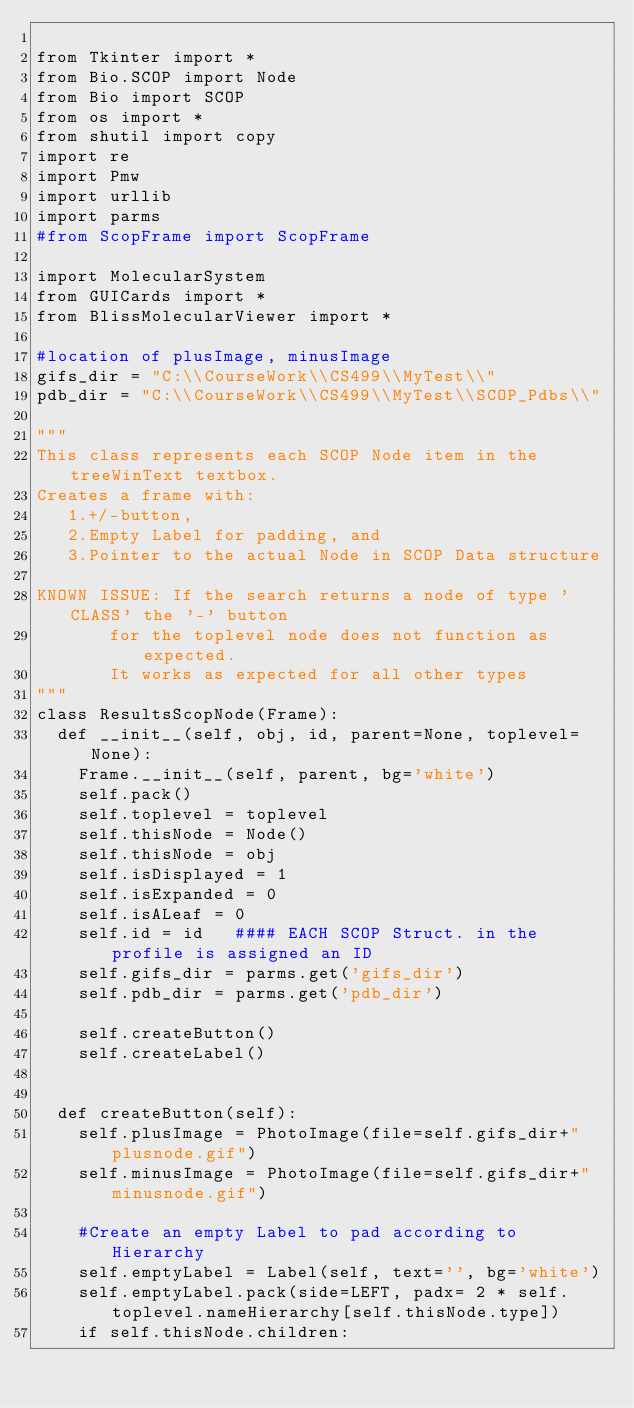<code> <loc_0><loc_0><loc_500><loc_500><_Python_>
from Tkinter import *
from Bio.SCOP import Node
from Bio import SCOP
from os import *
from shutil import copy
import re
import Pmw
import urllib
import parms
#from ScopFrame import ScopFrame

import MolecularSystem
from GUICards import *
from BlissMolecularViewer import *

#location of plusImage, minusImage
gifs_dir = "C:\\CourseWork\\CS499\\MyTest\\"
pdb_dir = "C:\\CourseWork\\CS499\\MyTest\\SCOP_Pdbs\\"

"""
This class represents each SCOP Node item in the treeWinText textbox.
Creates a frame with:
	 1.+/-button, 
	 2.Empty Label for padding, and  
	 3.Pointer to the actual Node in SCOP Data structure

KNOWN ISSUE: If the search returns a node of type 'CLASS' the '-' button 
	     for the toplevel node does not function as expected. 
	     It works as expected for all other types
"""
class ResultsScopNode(Frame):
	def __init__(self, obj, id, parent=None, toplevel=None):
		Frame.__init__(self, parent, bg='white')
		self.pack()
		self.toplevel = toplevel
		self.thisNode = Node()
		self.thisNode = obj
		self.isDisplayed = 1
		self.isExpanded = 0
		self.isALeaf = 0
		self.id = id   #### EACH SCOP Struct. in the profile is assigned an ID
		self.gifs_dir = parms.get('gifs_dir')
		self.pdb_dir = parms.get('pdb_dir')

		self.createButton()
		self.createLabel()


	def createButton(self):
		self.plusImage = PhotoImage(file=self.gifs_dir+"plusnode.gif")
		self.minusImage = PhotoImage(file=self.gifs_dir+"minusnode.gif")
		
		#Create an empty Label to pad according to Hierarchy
		self.emptyLabel = Label(self, text='', bg='white')
		self.emptyLabel.pack(side=LEFT, padx= 2 * self.toplevel.nameHierarchy[self.thisNode.type])
		if self.thisNode.children:</code> 